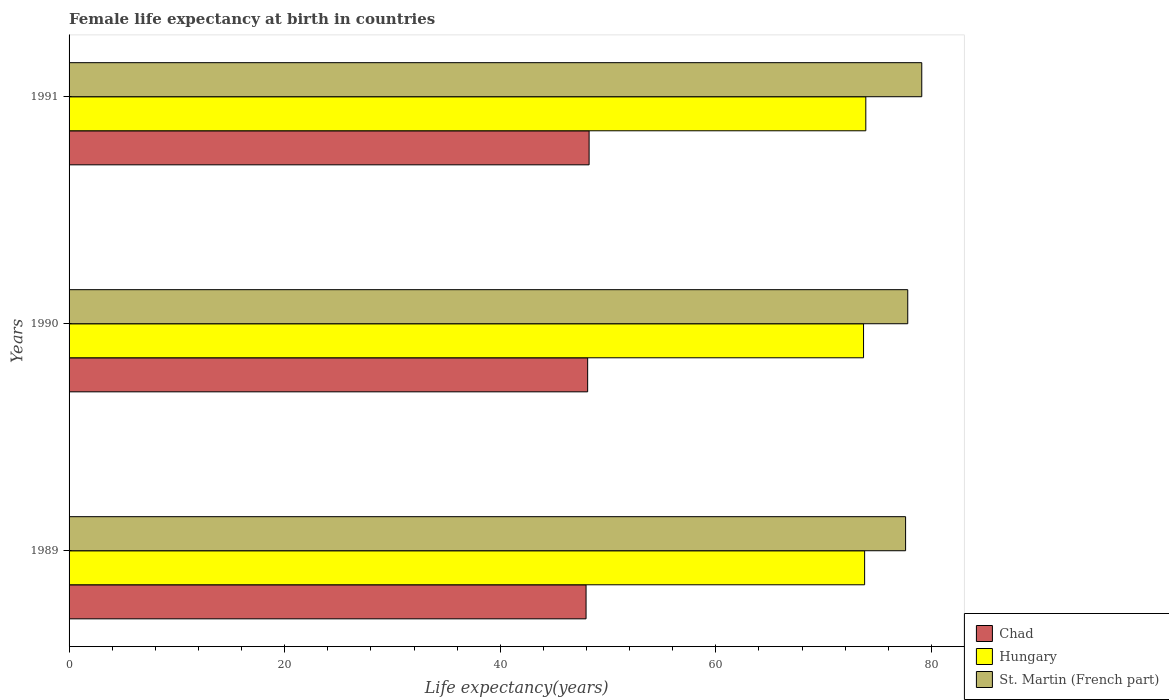Are the number of bars per tick equal to the number of legend labels?
Make the answer very short. Yes. How many bars are there on the 3rd tick from the top?
Ensure brevity in your answer.  3. In how many cases, is the number of bars for a given year not equal to the number of legend labels?
Your answer should be very brief. 0. What is the female life expectancy at birth in St. Martin (French part) in 1991?
Keep it short and to the point. 79.1. Across all years, what is the maximum female life expectancy at birth in Chad?
Make the answer very short. 48.24. Across all years, what is the minimum female life expectancy at birth in Chad?
Your answer should be compact. 47.96. In which year was the female life expectancy at birth in Chad minimum?
Offer a very short reply. 1989. What is the total female life expectancy at birth in Chad in the graph?
Keep it short and to the point. 144.31. What is the difference between the female life expectancy at birth in St. Martin (French part) in 1989 and that in 1991?
Provide a short and direct response. -1.5. What is the difference between the female life expectancy at birth in Hungary in 1990 and the female life expectancy at birth in St. Martin (French part) in 1989?
Offer a terse response. -3.9. What is the average female life expectancy at birth in St. Martin (French part) per year?
Provide a short and direct response. 78.17. In the year 1989, what is the difference between the female life expectancy at birth in St. Martin (French part) and female life expectancy at birth in Hungary?
Give a very brief answer. 3.8. What is the ratio of the female life expectancy at birth in Chad in 1989 to that in 1990?
Provide a short and direct response. 1. What is the difference between the highest and the second highest female life expectancy at birth in St. Martin (French part)?
Your answer should be compact. 1.3. What is the difference between the highest and the lowest female life expectancy at birth in St. Martin (French part)?
Keep it short and to the point. 1.5. In how many years, is the female life expectancy at birth in Hungary greater than the average female life expectancy at birth in Hungary taken over all years?
Provide a short and direct response. 1. Is the sum of the female life expectancy at birth in Hungary in 1990 and 1991 greater than the maximum female life expectancy at birth in Chad across all years?
Give a very brief answer. Yes. What does the 2nd bar from the top in 1989 represents?
Keep it short and to the point. Hungary. What does the 3rd bar from the bottom in 1989 represents?
Offer a terse response. St. Martin (French part). Is it the case that in every year, the sum of the female life expectancy at birth in Chad and female life expectancy at birth in Hungary is greater than the female life expectancy at birth in St. Martin (French part)?
Provide a succinct answer. Yes. How many bars are there?
Your response must be concise. 9. What is the difference between two consecutive major ticks on the X-axis?
Your answer should be compact. 20. Are the values on the major ticks of X-axis written in scientific E-notation?
Provide a short and direct response. No. Where does the legend appear in the graph?
Your answer should be very brief. Bottom right. How many legend labels are there?
Provide a short and direct response. 3. What is the title of the graph?
Offer a terse response. Female life expectancy at birth in countries. Does "Channel Islands" appear as one of the legend labels in the graph?
Your response must be concise. No. What is the label or title of the X-axis?
Your response must be concise. Life expectancy(years). What is the Life expectancy(years) in Chad in 1989?
Your answer should be very brief. 47.96. What is the Life expectancy(years) in Hungary in 1989?
Your response must be concise. 73.8. What is the Life expectancy(years) in St. Martin (French part) in 1989?
Your answer should be compact. 77.6. What is the Life expectancy(years) of Chad in 1990?
Offer a very short reply. 48.11. What is the Life expectancy(years) of Hungary in 1990?
Your answer should be compact. 73.7. What is the Life expectancy(years) in St. Martin (French part) in 1990?
Ensure brevity in your answer.  77.8. What is the Life expectancy(years) in Chad in 1991?
Your answer should be very brief. 48.24. What is the Life expectancy(years) of Hungary in 1991?
Offer a terse response. 73.91. What is the Life expectancy(years) in St. Martin (French part) in 1991?
Make the answer very short. 79.1. Across all years, what is the maximum Life expectancy(years) in Chad?
Your response must be concise. 48.24. Across all years, what is the maximum Life expectancy(years) in Hungary?
Your answer should be very brief. 73.91. Across all years, what is the maximum Life expectancy(years) of St. Martin (French part)?
Provide a short and direct response. 79.1. Across all years, what is the minimum Life expectancy(years) of Chad?
Provide a succinct answer. 47.96. Across all years, what is the minimum Life expectancy(years) in Hungary?
Provide a succinct answer. 73.7. Across all years, what is the minimum Life expectancy(years) of St. Martin (French part)?
Ensure brevity in your answer.  77.6. What is the total Life expectancy(years) in Chad in the graph?
Offer a very short reply. 144.31. What is the total Life expectancy(years) in Hungary in the graph?
Your answer should be compact. 221.41. What is the total Life expectancy(years) in St. Martin (French part) in the graph?
Your answer should be very brief. 234.5. What is the difference between the Life expectancy(years) in Chad in 1989 and that in 1990?
Your answer should be very brief. -0.15. What is the difference between the Life expectancy(years) of Hungary in 1989 and that in 1990?
Ensure brevity in your answer.  0.1. What is the difference between the Life expectancy(years) of St. Martin (French part) in 1989 and that in 1990?
Give a very brief answer. -0.2. What is the difference between the Life expectancy(years) of Chad in 1989 and that in 1991?
Your answer should be very brief. -0.28. What is the difference between the Life expectancy(years) in Hungary in 1989 and that in 1991?
Give a very brief answer. -0.11. What is the difference between the Life expectancy(years) in St. Martin (French part) in 1989 and that in 1991?
Provide a short and direct response. -1.5. What is the difference between the Life expectancy(years) of Chad in 1990 and that in 1991?
Provide a short and direct response. -0.14. What is the difference between the Life expectancy(years) of Hungary in 1990 and that in 1991?
Give a very brief answer. -0.21. What is the difference between the Life expectancy(years) of St. Martin (French part) in 1990 and that in 1991?
Offer a very short reply. -1.3. What is the difference between the Life expectancy(years) in Chad in 1989 and the Life expectancy(years) in Hungary in 1990?
Provide a succinct answer. -25.74. What is the difference between the Life expectancy(years) of Chad in 1989 and the Life expectancy(years) of St. Martin (French part) in 1990?
Make the answer very short. -29.84. What is the difference between the Life expectancy(years) in Hungary in 1989 and the Life expectancy(years) in St. Martin (French part) in 1990?
Your response must be concise. -4. What is the difference between the Life expectancy(years) in Chad in 1989 and the Life expectancy(years) in Hungary in 1991?
Keep it short and to the point. -25.95. What is the difference between the Life expectancy(years) of Chad in 1989 and the Life expectancy(years) of St. Martin (French part) in 1991?
Your answer should be compact. -31.14. What is the difference between the Life expectancy(years) in Chad in 1990 and the Life expectancy(years) in Hungary in 1991?
Your response must be concise. -25.8. What is the difference between the Life expectancy(years) of Chad in 1990 and the Life expectancy(years) of St. Martin (French part) in 1991?
Provide a short and direct response. -30.99. What is the average Life expectancy(years) of Chad per year?
Provide a succinct answer. 48.1. What is the average Life expectancy(years) of Hungary per year?
Provide a short and direct response. 73.8. What is the average Life expectancy(years) in St. Martin (French part) per year?
Provide a short and direct response. 78.17. In the year 1989, what is the difference between the Life expectancy(years) of Chad and Life expectancy(years) of Hungary?
Ensure brevity in your answer.  -25.84. In the year 1989, what is the difference between the Life expectancy(years) of Chad and Life expectancy(years) of St. Martin (French part)?
Provide a short and direct response. -29.64. In the year 1990, what is the difference between the Life expectancy(years) of Chad and Life expectancy(years) of Hungary?
Offer a very short reply. -25.59. In the year 1990, what is the difference between the Life expectancy(years) in Chad and Life expectancy(years) in St. Martin (French part)?
Offer a very short reply. -29.69. In the year 1991, what is the difference between the Life expectancy(years) of Chad and Life expectancy(years) of Hungary?
Provide a succinct answer. -25.67. In the year 1991, what is the difference between the Life expectancy(years) in Chad and Life expectancy(years) in St. Martin (French part)?
Your response must be concise. -30.86. In the year 1991, what is the difference between the Life expectancy(years) in Hungary and Life expectancy(years) in St. Martin (French part)?
Your answer should be compact. -5.19. What is the ratio of the Life expectancy(years) of Chad in 1989 to that in 1990?
Provide a succinct answer. 1. What is the ratio of the Life expectancy(years) of Hungary in 1989 to that in 1990?
Provide a succinct answer. 1. What is the ratio of the Life expectancy(years) of St. Martin (French part) in 1989 to that in 1990?
Offer a terse response. 1. What is the ratio of the Life expectancy(years) in St. Martin (French part) in 1989 to that in 1991?
Provide a succinct answer. 0.98. What is the ratio of the Life expectancy(years) of Chad in 1990 to that in 1991?
Keep it short and to the point. 1. What is the ratio of the Life expectancy(years) in Hungary in 1990 to that in 1991?
Your response must be concise. 1. What is the ratio of the Life expectancy(years) of St. Martin (French part) in 1990 to that in 1991?
Keep it short and to the point. 0.98. What is the difference between the highest and the second highest Life expectancy(years) in Chad?
Provide a succinct answer. 0.14. What is the difference between the highest and the second highest Life expectancy(years) in Hungary?
Give a very brief answer. 0.11. What is the difference between the highest and the second highest Life expectancy(years) of St. Martin (French part)?
Offer a terse response. 1.3. What is the difference between the highest and the lowest Life expectancy(years) in Chad?
Offer a terse response. 0.28. What is the difference between the highest and the lowest Life expectancy(years) of Hungary?
Provide a succinct answer. 0.21. What is the difference between the highest and the lowest Life expectancy(years) in St. Martin (French part)?
Keep it short and to the point. 1.5. 